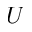<formula> <loc_0><loc_0><loc_500><loc_500>U</formula> 